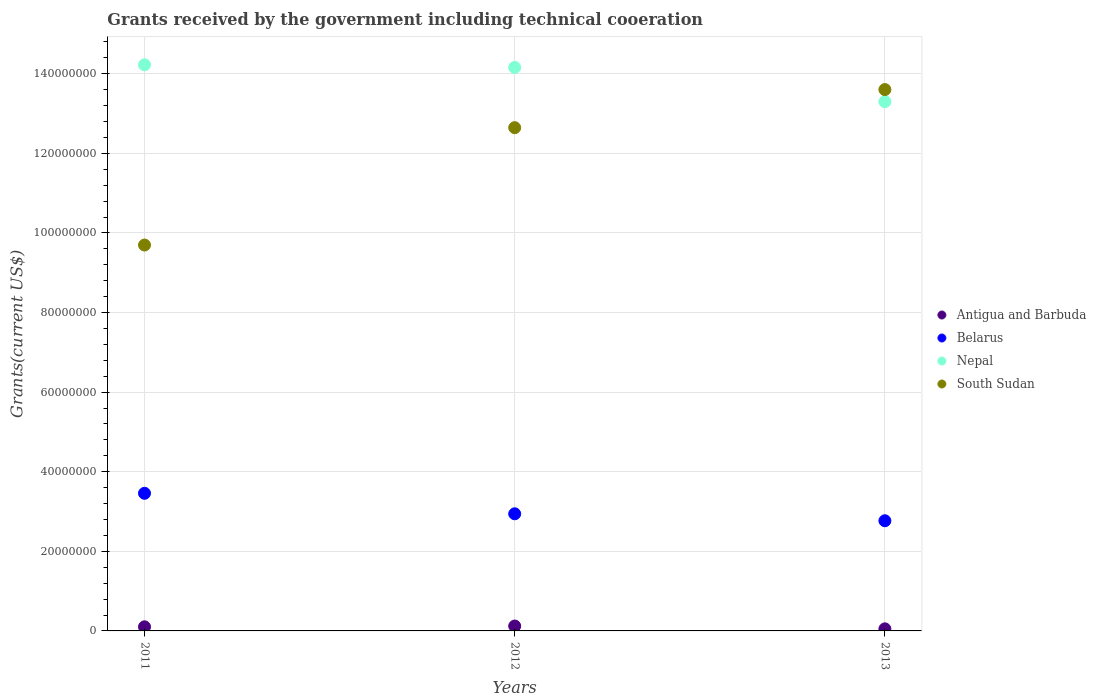What is the total grants received by the government in South Sudan in 2013?
Ensure brevity in your answer.  1.36e+08. Across all years, what is the maximum total grants received by the government in South Sudan?
Ensure brevity in your answer.  1.36e+08. Across all years, what is the minimum total grants received by the government in Antigua and Barbuda?
Give a very brief answer. 5.20e+05. In which year was the total grants received by the government in South Sudan maximum?
Your response must be concise. 2013. In which year was the total grants received by the government in South Sudan minimum?
Offer a very short reply. 2011. What is the total total grants received by the government in Belarus in the graph?
Offer a very short reply. 9.17e+07. What is the difference between the total grants received by the government in South Sudan in 2012 and that in 2013?
Offer a very short reply. -9.57e+06. What is the difference between the total grants received by the government in Belarus in 2011 and the total grants received by the government in Nepal in 2013?
Provide a succinct answer. -9.84e+07. What is the average total grants received by the government in Nepal per year?
Ensure brevity in your answer.  1.39e+08. In the year 2012, what is the difference between the total grants received by the government in Antigua and Barbuda and total grants received by the government in South Sudan?
Ensure brevity in your answer.  -1.25e+08. What is the ratio of the total grants received by the government in Antigua and Barbuda in 2011 to that in 2013?
Offer a terse response. 1.98. Is the total grants received by the government in Antigua and Barbuda in 2011 less than that in 2012?
Make the answer very short. Yes. Is the difference between the total grants received by the government in Antigua and Barbuda in 2011 and 2013 greater than the difference between the total grants received by the government in South Sudan in 2011 and 2013?
Your response must be concise. Yes. What is the difference between the highest and the second highest total grants received by the government in South Sudan?
Provide a succinct answer. 9.57e+06. What is the difference between the highest and the lowest total grants received by the government in South Sudan?
Make the answer very short. 3.91e+07. Is the sum of the total grants received by the government in Antigua and Barbuda in 2012 and 2013 greater than the maximum total grants received by the government in Belarus across all years?
Give a very brief answer. No. Is it the case that in every year, the sum of the total grants received by the government in Nepal and total grants received by the government in South Sudan  is greater than the sum of total grants received by the government in Belarus and total grants received by the government in Antigua and Barbuda?
Ensure brevity in your answer.  Yes. Is it the case that in every year, the sum of the total grants received by the government in South Sudan and total grants received by the government in Antigua and Barbuda  is greater than the total grants received by the government in Belarus?
Your answer should be compact. Yes. Does the total grants received by the government in Nepal monotonically increase over the years?
Your answer should be compact. No. Is the total grants received by the government in Antigua and Barbuda strictly greater than the total grants received by the government in Belarus over the years?
Your answer should be compact. No. How many years are there in the graph?
Give a very brief answer. 3. What is the difference between two consecutive major ticks on the Y-axis?
Make the answer very short. 2.00e+07. Does the graph contain grids?
Your answer should be very brief. Yes. Where does the legend appear in the graph?
Provide a short and direct response. Center right. What is the title of the graph?
Offer a very short reply. Grants received by the government including technical cooeration. What is the label or title of the Y-axis?
Offer a very short reply. Grants(current US$). What is the Grants(current US$) of Antigua and Barbuda in 2011?
Offer a terse response. 1.03e+06. What is the Grants(current US$) of Belarus in 2011?
Keep it short and to the point. 3.46e+07. What is the Grants(current US$) in Nepal in 2011?
Give a very brief answer. 1.42e+08. What is the Grants(current US$) of South Sudan in 2011?
Your answer should be compact. 9.70e+07. What is the Grants(current US$) of Antigua and Barbuda in 2012?
Give a very brief answer. 1.23e+06. What is the Grants(current US$) in Belarus in 2012?
Give a very brief answer. 2.94e+07. What is the Grants(current US$) of Nepal in 2012?
Your answer should be compact. 1.42e+08. What is the Grants(current US$) of South Sudan in 2012?
Your response must be concise. 1.26e+08. What is the Grants(current US$) of Antigua and Barbuda in 2013?
Ensure brevity in your answer.  5.20e+05. What is the Grants(current US$) in Belarus in 2013?
Provide a succinct answer. 2.77e+07. What is the Grants(current US$) in Nepal in 2013?
Offer a very short reply. 1.33e+08. What is the Grants(current US$) of South Sudan in 2013?
Your response must be concise. 1.36e+08. Across all years, what is the maximum Grants(current US$) of Antigua and Barbuda?
Offer a terse response. 1.23e+06. Across all years, what is the maximum Grants(current US$) of Belarus?
Keep it short and to the point. 3.46e+07. Across all years, what is the maximum Grants(current US$) in Nepal?
Give a very brief answer. 1.42e+08. Across all years, what is the maximum Grants(current US$) in South Sudan?
Your response must be concise. 1.36e+08. Across all years, what is the minimum Grants(current US$) in Antigua and Barbuda?
Your response must be concise. 5.20e+05. Across all years, what is the minimum Grants(current US$) of Belarus?
Your answer should be compact. 2.77e+07. Across all years, what is the minimum Grants(current US$) in Nepal?
Keep it short and to the point. 1.33e+08. Across all years, what is the minimum Grants(current US$) in South Sudan?
Make the answer very short. 9.70e+07. What is the total Grants(current US$) of Antigua and Barbuda in the graph?
Your answer should be compact. 2.78e+06. What is the total Grants(current US$) in Belarus in the graph?
Provide a succinct answer. 9.17e+07. What is the total Grants(current US$) of Nepal in the graph?
Your answer should be very brief. 4.17e+08. What is the total Grants(current US$) of South Sudan in the graph?
Ensure brevity in your answer.  3.59e+08. What is the difference between the Grants(current US$) in Antigua and Barbuda in 2011 and that in 2012?
Provide a succinct answer. -2.00e+05. What is the difference between the Grants(current US$) of Belarus in 2011 and that in 2012?
Ensure brevity in your answer.  5.15e+06. What is the difference between the Grants(current US$) in Nepal in 2011 and that in 2012?
Ensure brevity in your answer.  6.70e+05. What is the difference between the Grants(current US$) in South Sudan in 2011 and that in 2012?
Ensure brevity in your answer.  -2.95e+07. What is the difference between the Grants(current US$) in Antigua and Barbuda in 2011 and that in 2013?
Provide a short and direct response. 5.10e+05. What is the difference between the Grants(current US$) of Belarus in 2011 and that in 2013?
Provide a succinct answer. 6.90e+06. What is the difference between the Grants(current US$) of Nepal in 2011 and that in 2013?
Ensure brevity in your answer.  9.26e+06. What is the difference between the Grants(current US$) in South Sudan in 2011 and that in 2013?
Offer a very short reply. -3.91e+07. What is the difference between the Grants(current US$) of Antigua and Barbuda in 2012 and that in 2013?
Provide a short and direct response. 7.10e+05. What is the difference between the Grants(current US$) in Belarus in 2012 and that in 2013?
Your answer should be compact. 1.75e+06. What is the difference between the Grants(current US$) in Nepal in 2012 and that in 2013?
Offer a terse response. 8.59e+06. What is the difference between the Grants(current US$) of South Sudan in 2012 and that in 2013?
Make the answer very short. -9.57e+06. What is the difference between the Grants(current US$) in Antigua and Barbuda in 2011 and the Grants(current US$) in Belarus in 2012?
Give a very brief answer. -2.84e+07. What is the difference between the Grants(current US$) of Antigua and Barbuda in 2011 and the Grants(current US$) of Nepal in 2012?
Give a very brief answer. -1.41e+08. What is the difference between the Grants(current US$) in Antigua and Barbuda in 2011 and the Grants(current US$) in South Sudan in 2012?
Provide a short and direct response. -1.25e+08. What is the difference between the Grants(current US$) of Belarus in 2011 and the Grants(current US$) of Nepal in 2012?
Offer a very short reply. -1.07e+08. What is the difference between the Grants(current US$) in Belarus in 2011 and the Grants(current US$) in South Sudan in 2012?
Make the answer very short. -9.19e+07. What is the difference between the Grants(current US$) of Nepal in 2011 and the Grants(current US$) of South Sudan in 2012?
Make the answer very short. 1.58e+07. What is the difference between the Grants(current US$) in Antigua and Barbuda in 2011 and the Grants(current US$) in Belarus in 2013?
Ensure brevity in your answer.  -2.66e+07. What is the difference between the Grants(current US$) of Antigua and Barbuda in 2011 and the Grants(current US$) of Nepal in 2013?
Offer a terse response. -1.32e+08. What is the difference between the Grants(current US$) in Antigua and Barbuda in 2011 and the Grants(current US$) in South Sudan in 2013?
Provide a succinct answer. -1.35e+08. What is the difference between the Grants(current US$) in Belarus in 2011 and the Grants(current US$) in Nepal in 2013?
Provide a short and direct response. -9.84e+07. What is the difference between the Grants(current US$) of Belarus in 2011 and the Grants(current US$) of South Sudan in 2013?
Provide a short and direct response. -1.01e+08. What is the difference between the Grants(current US$) of Nepal in 2011 and the Grants(current US$) of South Sudan in 2013?
Ensure brevity in your answer.  6.23e+06. What is the difference between the Grants(current US$) of Antigua and Barbuda in 2012 and the Grants(current US$) of Belarus in 2013?
Make the answer very short. -2.64e+07. What is the difference between the Grants(current US$) in Antigua and Barbuda in 2012 and the Grants(current US$) in Nepal in 2013?
Offer a very short reply. -1.32e+08. What is the difference between the Grants(current US$) in Antigua and Barbuda in 2012 and the Grants(current US$) in South Sudan in 2013?
Keep it short and to the point. -1.35e+08. What is the difference between the Grants(current US$) in Belarus in 2012 and the Grants(current US$) in Nepal in 2013?
Your answer should be very brief. -1.04e+08. What is the difference between the Grants(current US$) in Belarus in 2012 and the Grants(current US$) in South Sudan in 2013?
Give a very brief answer. -1.07e+08. What is the difference between the Grants(current US$) of Nepal in 2012 and the Grants(current US$) of South Sudan in 2013?
Provide a short and direct response. 5.56e+06. What is the average Grants(current US$) of Antigua and Barbuda per year?
Your response must be concise. 9.27e+05. What is the average Grants(current US$) in Belarus per year?
Provide a short and direct response. 3.06e+07. What is the average Grants(current US$) in Nepal per year?
Offer a very short reply. 1.39e+08. What is the average Grants(current US$) in South Sudan per year?
Offer a terse response. 1.20e+08. In the year 2011, what is the difference between the Grants(current US$) in Antigua and Barbuda and Grants(current US$) in Belarus?
Your answer should be very brief. -3.36e+07. In the year 2011, what is the difference between the Grants(current US$) in Antigua and Barbuda and Grants(current US$) in Nepal?
Provide a succinct answer. -1.41e+08. In the year 2011, what is the difference between the Grants(current US$) of Antigua and Barbuda and Grants(current US$) of South Sudan?
Ensure brevity in your answer.  -9.59e+07. In the year 2011, what is the difference between the Grants(current US$) of Belarus and Grants(current US$) of Nepal?
Give a very brief answer. -1.08e+08. In the year 2011, what is the difference between the Grants(current US$) in Belarus and Grants(current US$) in South Sudan?
Your response must be concise. -6.24e+07. In the year 2011, what is the difference between the Grants(current US$) in Nepal and Grants(current US$) in South Sudan?
Offer a terse response. 4.53e+07. In the year 2012, what is the difference between the Grants(current US$) of Antigua and Barbuda and Grants(current US$) of Belarus?
Offer a terse response. -2.82e+07. In the year 2012, what is the difference between the Grants(current US$) of Antigua and Barbuda and Grants(current US$) of Nepal?
Provide a short and direct response. -1.40e+08. In the year 2012, what is the difference between the Grants(current US$) of Antigua and Barbuda and Grants(current US$) of South Sudan?
Offer a terse response. -1.25e+08. In the year 2012, what is the difference between the Grants(current US$) in Belarus and Grants(current US$) in Nepal?
Give a very brief answer. -1.12e+08. In the year 2012, what is the difference between the Grants(current US$) of Belarus and Grants(current US$) of South Sudan?
Make the answer very short. -9.70e+07. In the year 2012, what is the difference between the Grants(current US$) in Nepal and Grants(current US$) in South Sudan?
Keep it short and to the point. 1.51e+07. In the year 2013, what is the difference between the Grants(current US$) in Antigua and Barbuda and Grants(current US$) in Belarus?
Ensure brevity in your answer.  -2.72e+07. In the year 2013, what is the difference between the Grants(current US$) in Antigua and Barbuda and Grants(current US$) in Nepal?
Your answer should be very brief. -1.32e+08. In the year 2013, what is the difference between the Grants(current US$) of Antigua and Barbuda and Grants(current US$) of South Sudan?
Your answer should be compact. -1.36e+08. In the year 2013, what is the difference between the Grants(current US$) in Belarus and Grants(current US$) in Nepal?
Offer a very short reply. -1.05e+08. In the year 2013, what is the difference between the Grants(current US$) in Belarus and Grants(current US$) in South Sudan?
Offer a terse response. -1.08e+08. In the year 2013, what is the difference between the Grants(current US$) in Nepal and Grants(current US$) in South Sudan?
Your answer should be very brief. -3.03e+06. What is the ratio of the Grants(current US$) of Antigua and Barbuda in 2011 to that in 2012?
Offer a very short reply. 0.84. What is the ratio of the Grants(current US$) in Belarus in 2011 to that in 2012?
Provide a short and direct response. 1.18. What is the ratio of the Grants(current US$) in South Sudan in 2011 to that in 2012?
Provide a short and direct response. 0.77. What is the ratio of the Grants(current US$) in Antigua and Barbuda in 2011 to that in 2013?
Your answer should be compact. 1.98. What is the ratio of the Grants(current US$) of Belarus in 2011 to that in 2013?
Provide a succinct answer. 1.25. What is the ratio of the Grants(current US$) of Nepal in 2011 to that in 2013?
Give a very brief answer. 1.07. What is the ratio of the Grants(current US$) in South Sudan in 2011 to that in 2013?
Your answer should be very brief. 0.71. What is the ratio of the Grants(current US$) in Antigua and Barbuda in 2012 to that in 2013?
Give a very brief answer. 2.37. What is the ratio of the Grants(current US$) in Belarus in 2012 to that in 2013?
Provide a short and direct response. 1.06. What is the ratio of the Grants(current US$) in Nepal in 2012 to that in 2013?
Your response must be concise. 1.06. What is the ratio of the Grants(current US$) in South Sudan in 2012 to that in 2013?
Your answer should be very brief. 0.93. What is the difference between the highest and the second highest Grants(current US$) in Antigua and Barbuda?
Offer a very short reply. 2.00e+05. What is the difference between the highest and the second highest Grants(current US$) in Belarus?
Give a very brief answer. 5.15e+06. What is the difference between the highest and the second highest Grants(current US$) in Nepal?
Ensure brevity in your answer.  6.70e+05. What is the difference between the highest and the second highest Grants(current US$) in South Sudan?
Offer a very short reply. 9.57e+06. What is the difference between the highest and the lowest Grants(current US$) in Antigua and Barbuda?
Offer a very short reply. 7.10e+05. What is the difference between the highest and the lowest Grants(current US$) in Belarus?
Your answer should be very brief. 6.90e+06. What is the difference between the highest and the lowest Grants(current US$) of Nepal?
Your response must be concise. 9.26e+06. What is the difference between the highest and the lowest Grants(current US$) in South Sudan?
Provide a short and direct response. 3.91e+07. 